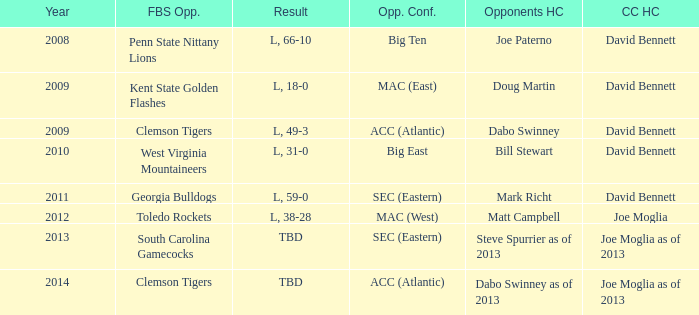What was the result when then opponents conference was Mac (east)? L, 18-0. 